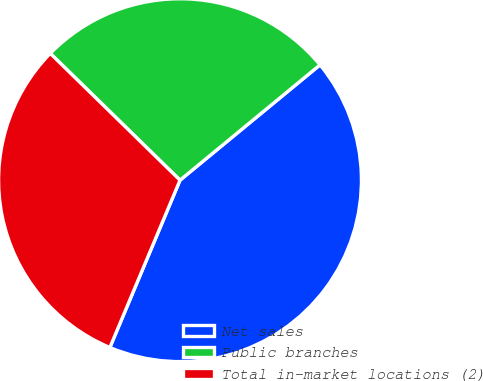Convert chart to OTSL. <chart><loc_0><loc_0><loc_500><loc_500><pie_chart><fcel>Net sales<fcel>Public branches<fcel>Total in-market locations (2)<nl><fcel>42.29%<fcel>26.72%<fcel>31.0%<nl></chart> 